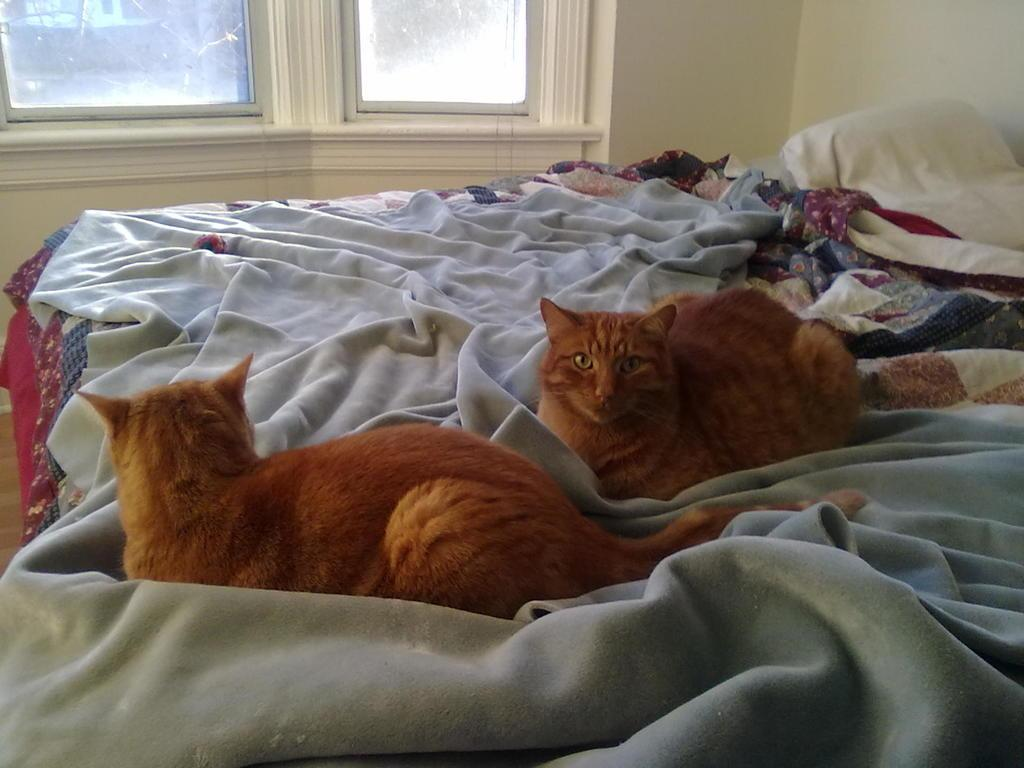How many cats are in the image? There are two cats in the image. What are the cats doing in the image? The cats are lying on the bed. What is covering the bed in the image? There is a blanket on the bed. What can be seen in the background of the image? There is a wall and a window in the background of the image. What color are the cats in the image? The cats are brown in color. Can you see a tin can being used as a toy by the cats in the image? There is no tin can present in the image; it only features two brown cats lying on the bed. 